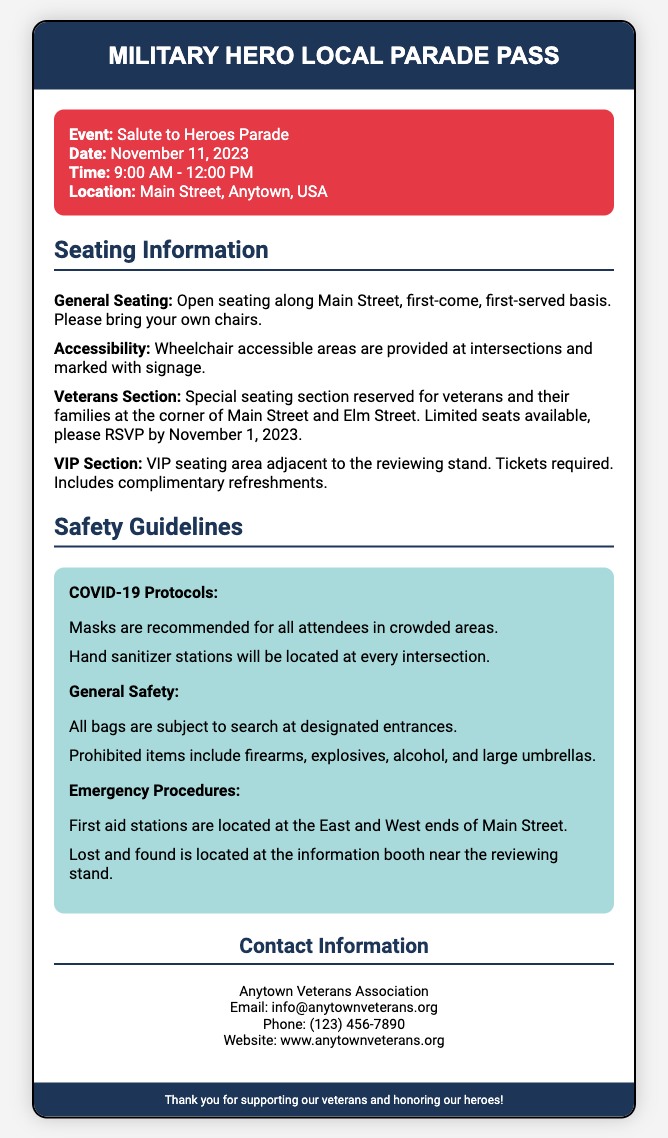What is the event name? The event name is specifically mentioned in the document under the event details section.
Answer: Salute to Heroes Parade What is the date of the parade? The date is explicitly listed in the event details section.
Answer: November 11, 2023 What time does the parade start? The start time is provided in the event details section.
Answer: 9:00 AM What is required for VIP seating? The document states that tickets are required for VIP seating.
Answer: Tickets How many first aid stations are specified? The document mentions first aid stations at two locations along the main street.
Answer: Two Where is the veterans section located? The veterans section is specifically identified in the seating information.
Answer: Corner of Main Street and Elm Street Are masks required? The document highlights recommendations regarding masks in crowded areas.
Answer: Recommended What should attendees bring for general seating? The document advises attendees to bring something for seating.
Answer: Chairs When should you RSVP for veterans seating? This detail can be found in the seating information section regarding veterans seating.
Answer: November 1, 2023 